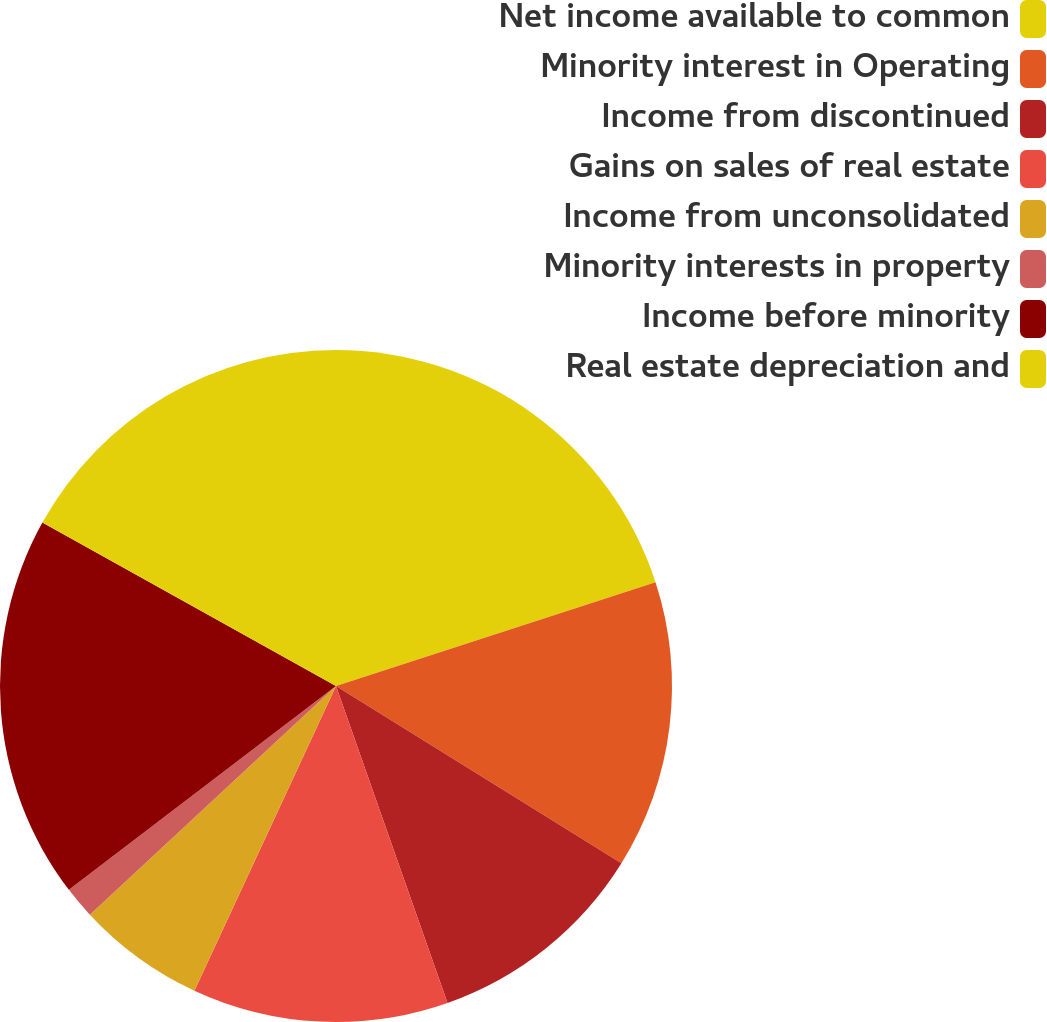Convert chart. <chart><loc_0><loc_0><loc_500><loc_500><pie_chart><fcel>Net income available to common<fcel>Minority interest in Operating<fcel>Income from discontinued<fcel>Gains on sales of real estate<fcel>Income from unconsolidated<fcel>Minority interests in property<fcel>Income before minority<fcel>Real estate depreciation and<nl><fcel>20.0%<fcel>13.85%<fcel>10.77%<fcel>12.31%<fcel>6.16%<fcel>1.54%<fcel>18.46%<fcel>16.92%<nl></chart> 